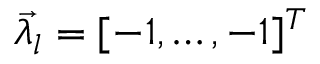Convert formula to latex. <formula><loc_0><loc_0><loc_500><loc_500>\vec { \lambda _ { l } } = [ - 1 , \dots , - 1 ] ^ { T }</formula> 